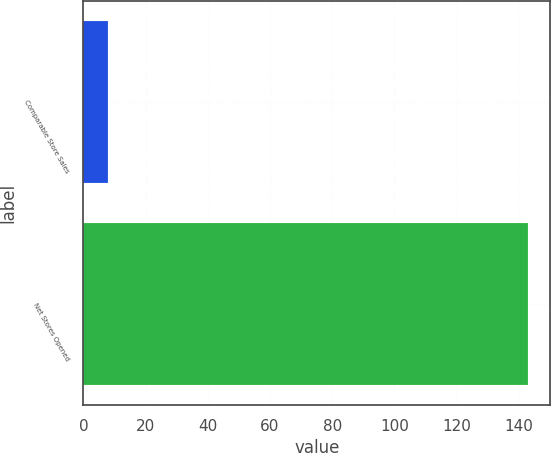<chart> <loc_0><loc_0><loc_500><loc_500><bar_chart><fcel>Comparable Store Sales<fcel>Net Stores Opened<nl><fcel>8<fcel>143<nl></chart> 